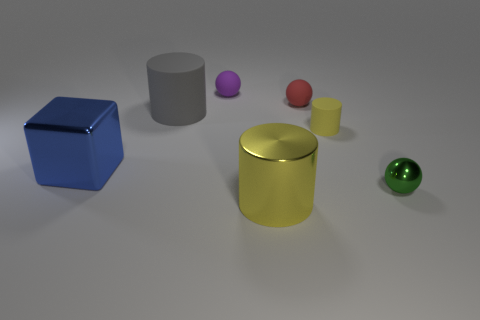Subtract 1 cylinders. How many cylinders are left? 2 Subtract all metal spheres. How many spheres are left? 2 Add 1 red rubber spheres. How many objects exist? 8 Subtract all blocks. How many objects are left? 6 Add 4 small cylinders. How many small cylinders are left? 5 Add 5 large blue metallic cylinders. How many large blue metallic cylinders exist? 5 Subtract 0 red blocks. How many objects are left? 7 Subtract all big rubber cubes. Subtract all small matte spheres. How many objects are left? 5 